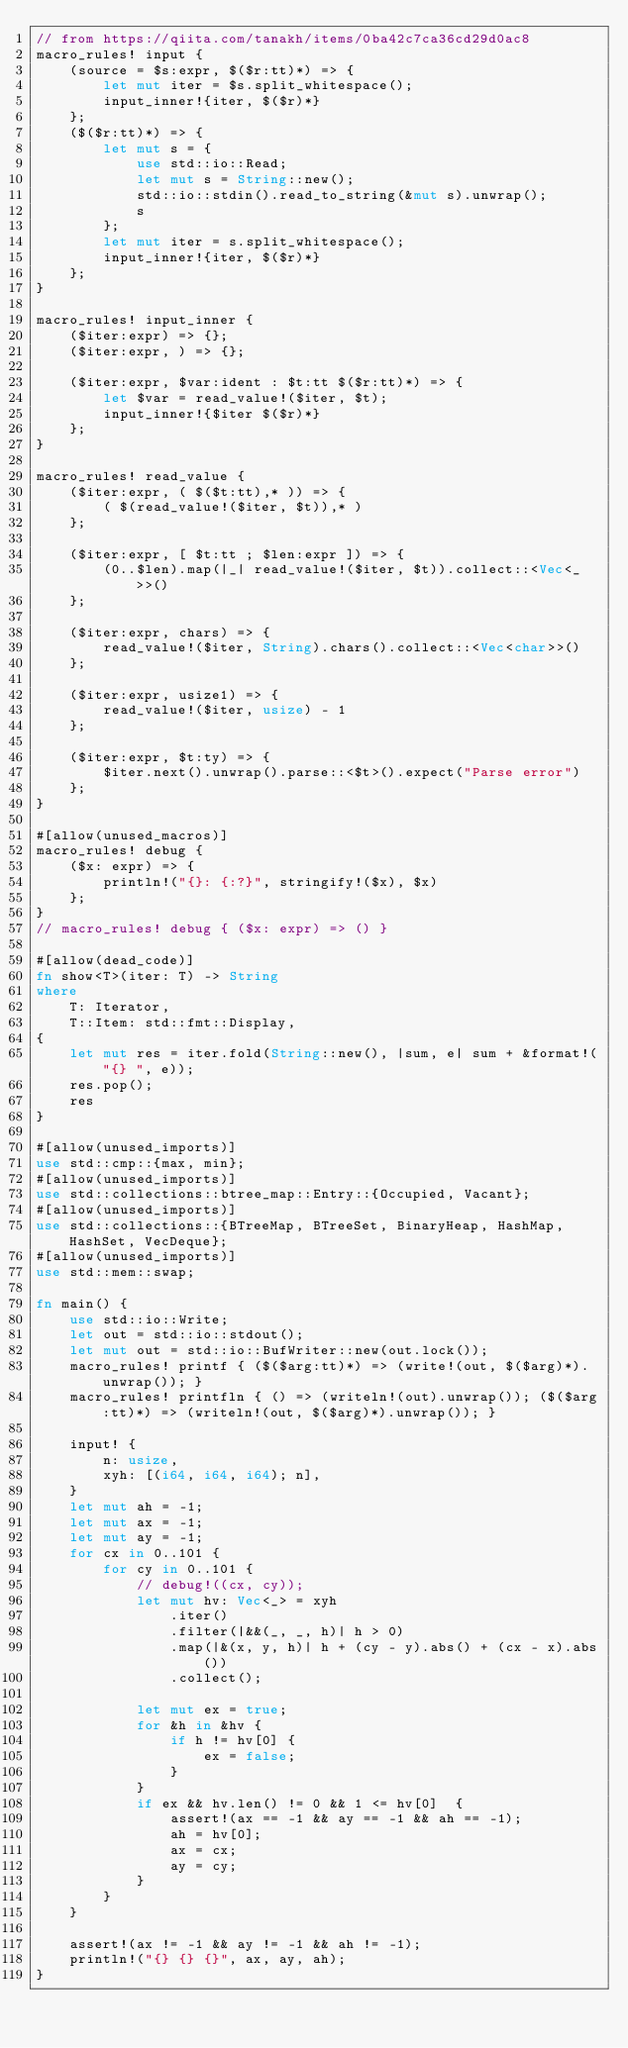<code> <loc_0><loc_0><loc_500><loc_500><_Rust_>// from https://qiita.com/tanakh/items/0ba42c7ca36cd29d0ac8
macro_rules! input {
    (source = $s:expr, $($r:tt)*) => {
        let mut iter = $s.split_whitespace();
        input_inner!{iter, $($r)*}
    };
    ($($r:tt)*) => {
        let mut s = {
            use std::io::Read;
            let mut s = String::new();
            std::io::stdin().read_to_string(&mut s).unwrap();
            s
        };
        let mut iter = s.split_whitespace();
        input_inner!{iter, $($r)*}
    };
}

macro_rules! input_inner {
    ($iter:expr) => {};
    ($iter:expr, ) => {};

    ($iter:expr, $var:ident : $t:tt $($r:tt)*) => {
        let $var = read_value!($iter, $t);
        input_inner!{$iter $($r)*}
    };
}

macro_rules! read_value {
    ($iter:expr, ( $($t:tt),* )) => {
        ( $(read_value!($iter, $t)),* )
    };

    ($iter:expr, [ $t:tt ; $len:expr ]) => {
        (0..$len).map(|_| read_value!($iter, $t)).collect::<Vec<_>>()
    };

    ($iter:expr, chars) => {
        read_value!($iter, String).chars().collect::<Vec<char>>()
    };

    ($iter:expr, usize1) => {
        read_value!($iter, usize) - 1
    };

    ($iter:expr, $t:ty) => {
        $iter.next().unwrap().parse::<$t>().expect("Parse error")
    };
}

#[allow(unused_macros)]
macro_rules! debug {
    ($x: expr) => {
        println!("{}: {:?}", stringify!($x), $x)
    };
}
// macro_rules! debug { ($x: expr) => () }

#[allow(dead_code)]
fn show<T>(iter: T) -> String
where
    T: Iterator,
    T::Item: std::fmt::Display,
{
    let mut res = iter.fold(String::new(), |sum, e| sum + &format!("{} ", e));
    res.pop();
    res
}

#[allow(unused_imports)]
use std::cmp::{max, min};
#[allow(unused_imports)]
use std::collections::btree_map::Entry::{Occupied, Vacant};
#[allow(unused_imports)]
use std::collections::{BTreeMap, BTreeSet, BinaryHeap, HashMap, HashSet, VecDeque};
#[allow(unused_imports)]
use std::mem::swap;

fn main() {
    use std::io::Write;
    let out = std::io::stdout();
    let mut out = std::io::BufWriter::new(out.lock());
    macro_rules! printf { ($($arg:tt)*) => (write!(out, $($arg)*).unwrap()); }
    macro_rules! printfln { () => (writeln!(out).unwrap()); ($($arg:tt)*) => (writeln!(out, $($arg)*).unwrap()); }

    input! {
        n: usize,
        xyh: [(i64, i64, i64); n],
    }
    let mut ah = -1;
    let mut ax = -1;
    let mut ay = -1;
    for cx in 0..101 {
        for cy in 0..101 {
            // debug!((cx, cy));
            let mut hv: Vec<_> = xyh
                .iter()
                .filter(|&&(_, _, h)| h > 0)
                .map(|&(x, y, h)| h + (cy - y).abs() + (cx - x).abs())
                .collect();
            
            let mut ex = true;
            for &h in &hv {
                if h != hv[0] {
                    ex = false;
                }
            }
            if ex && hv.len() != 0 && 1 <= hv[0]  {
                assert!(ax == -1 && ay == -1 && ah == -1);
                ah = hv[0];
                ax = cx;
                ay = cy;
            }
        }
    }

    assert!(ax != -1 && ay != -1 && ah != -1);
    println!("{} {} {}", ax, ay, ah);
}
</code> 